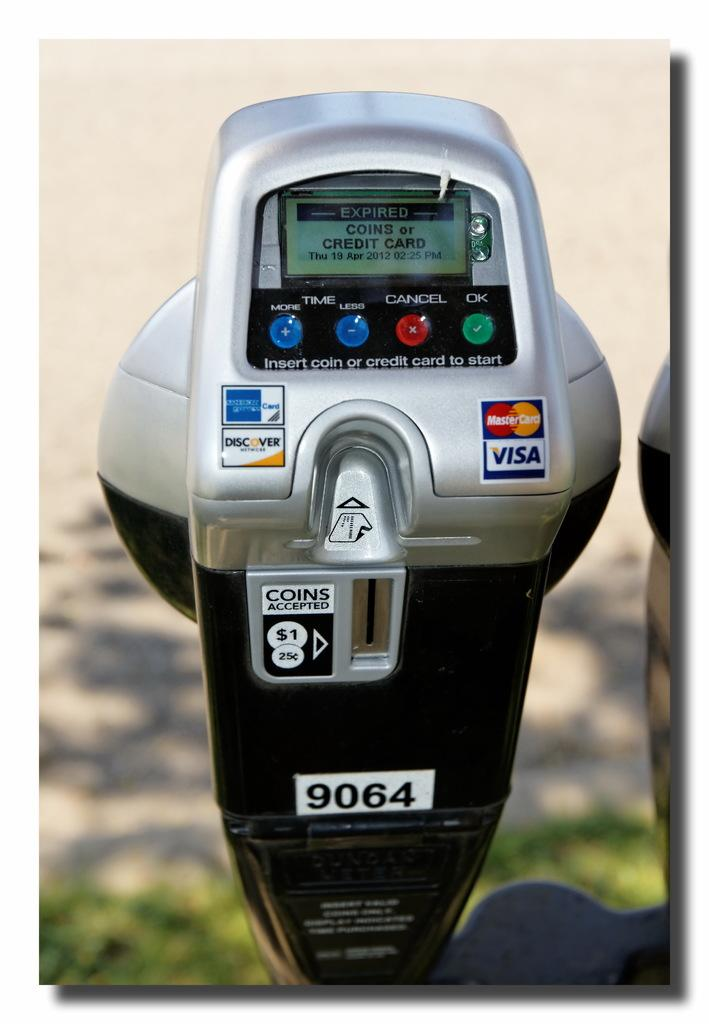<image>
Present a compact description of the photo's key features. A parking meter that accepts coils, American Express, Discover, Mastercard, or Visa. 